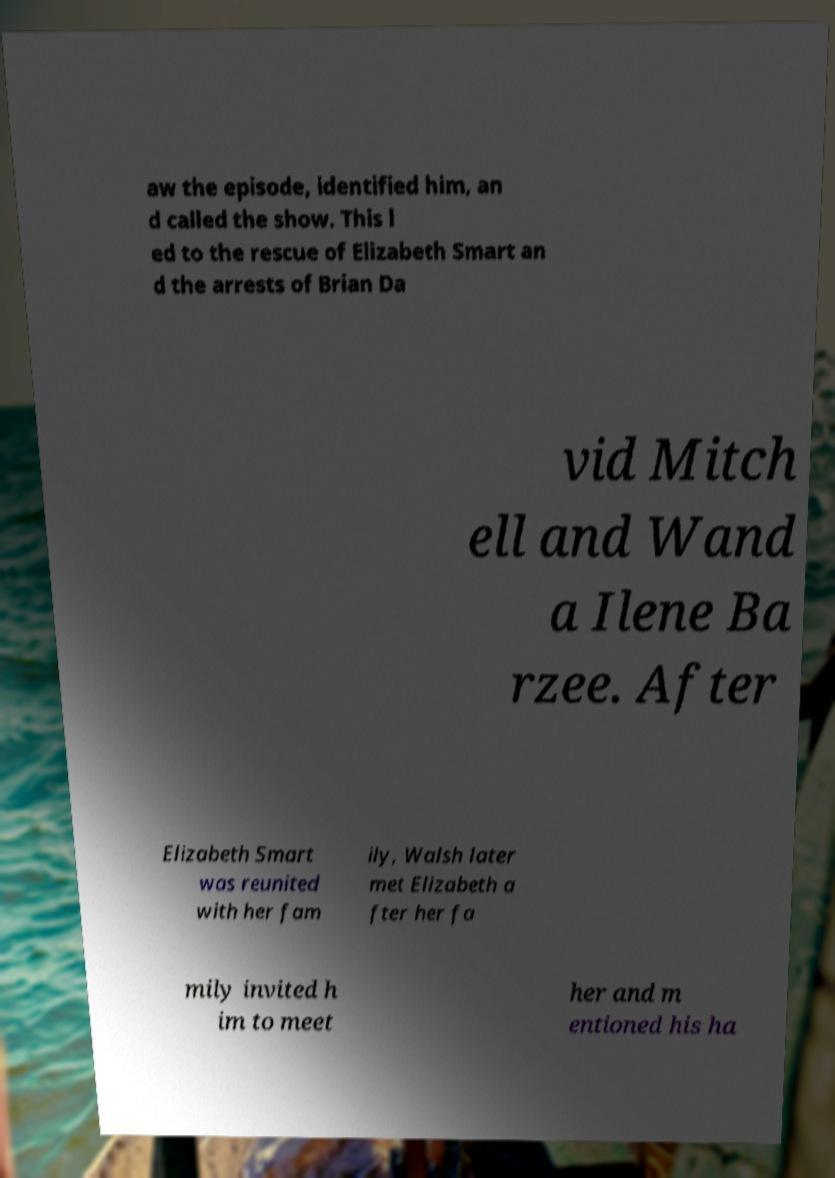There's text embedded in this image that I need extracted. Can you transcribe it verbatim? aw the episode, identified him, an d called the show. This l ed to the rescue of Elizabeth Smart an d the arrests of Brian Da vid Mitch ell and Wand a Ilene Ba rzee. After Elizabeth Smart was reunited with her fam ily, Walsh later met Elizabeth a fter her fa mily invited h im to meet her and m entioned his ha 